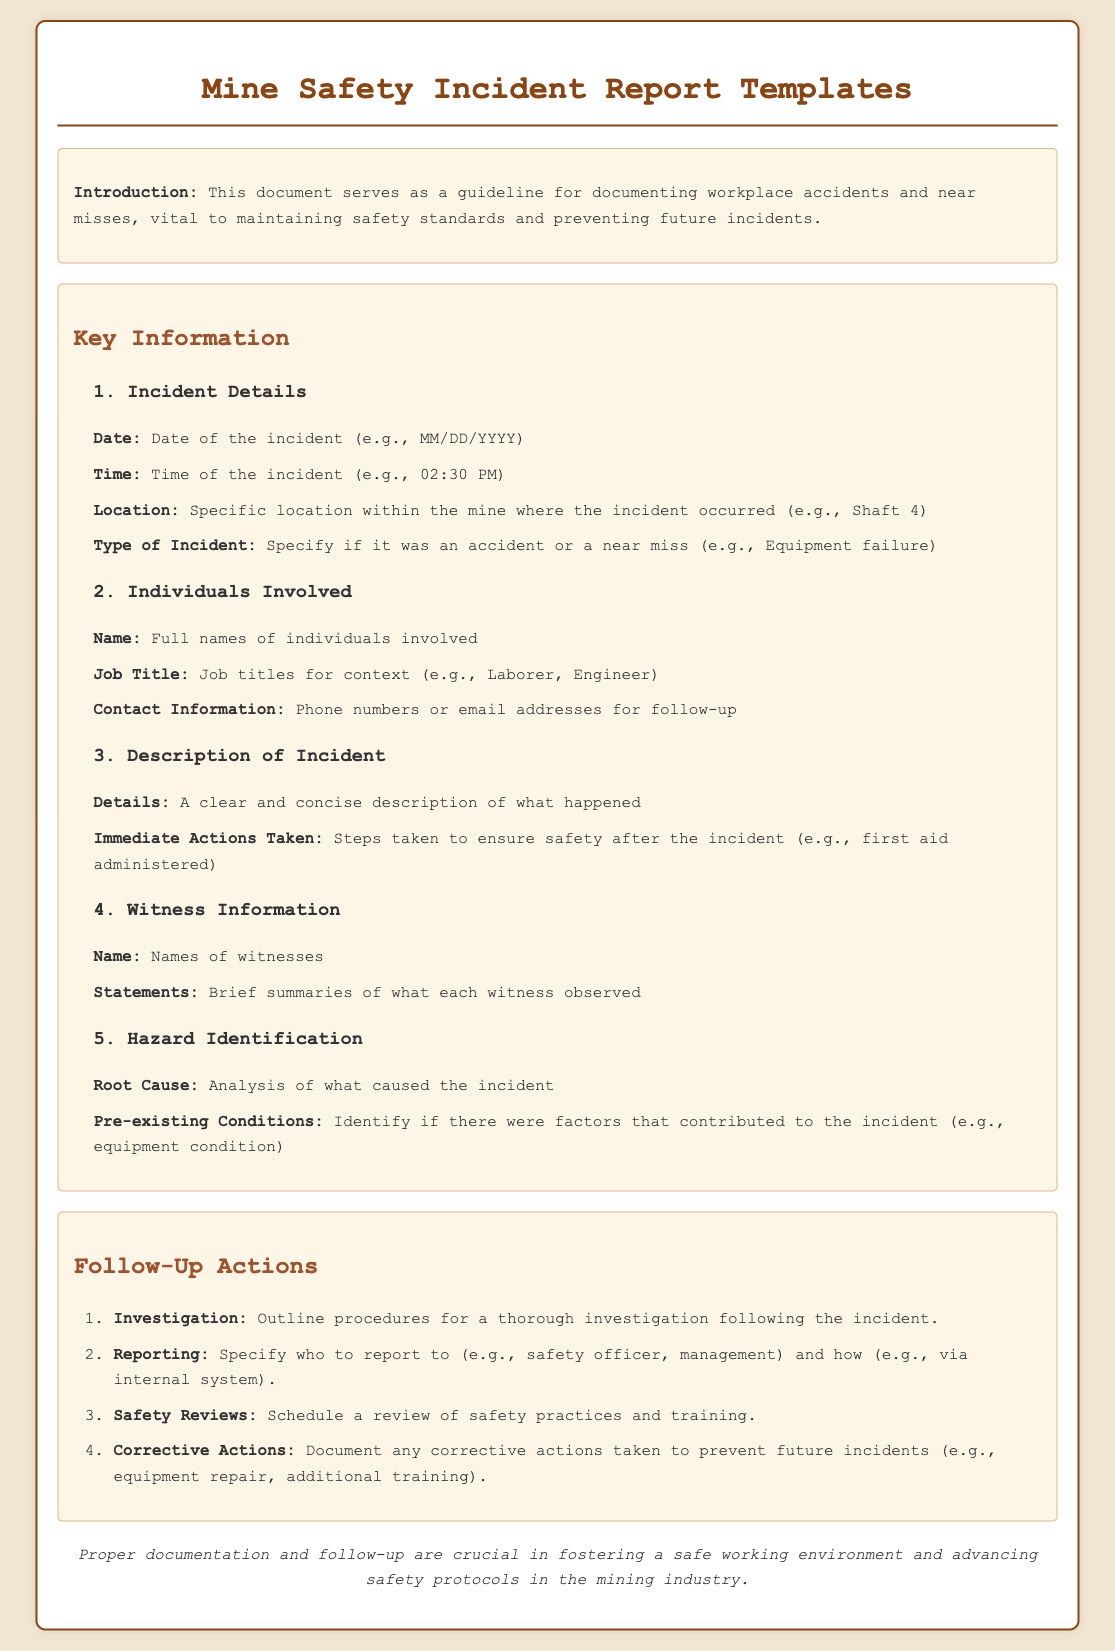what is the date format for the incident? The document specifies the date format as "MM/DD/YYYY".
Answer: MM/DD/YYYY what is required in the "Description of Incident" section? This section requires a clear and concise description of what happened and the immediate actions taken.
Answer: Details and Immediate Actions Taken who should be reported to after an incident? The document states that reports should be made to the safety officer or management.
Answer: Safety officer, management what type of information is listed under "Individuals Involved"? This section includes the full names, job titles, and contact information of individuals involved.
Answer: Full names, Job titles, Contact Information what should be outlined in the follow-up actions? The follow-up actions include investigation procedures, reporting, safety reviews, and corrective actions.
Answer: Investigation, Reporting, Safety Reviews, Corrective Actions how many sections are there under Key Information? There are five subsections under the Key Information section.
Answer: Five what is the primary purpose of this document? The primary purpose is to provide guidelines for documenting workplace accidents and near misses.
Answer: Guidelines for documenting workplace accidents and near misses what is identified in the "Hazard Identification" subsection? This subsection identifies the root cause and any pre-existing conditions contributing to the incident.
Answer: Root Cause and Pre-existing Conditions 